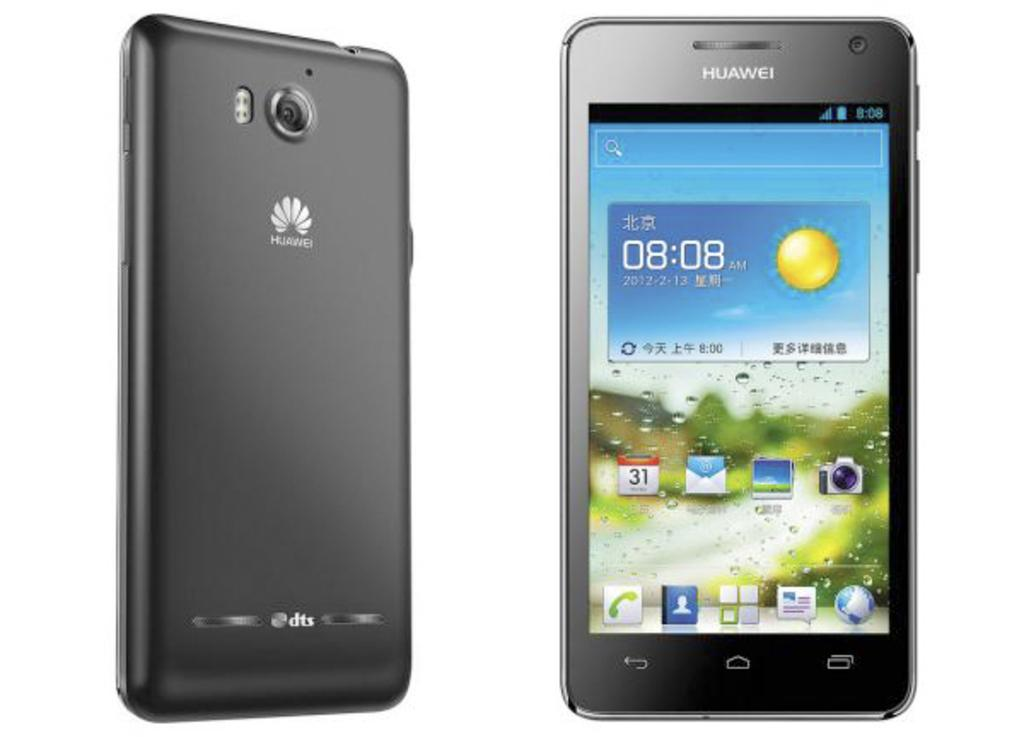<image>
Describe the image concisely. The front and back of a black Huawei phone. 